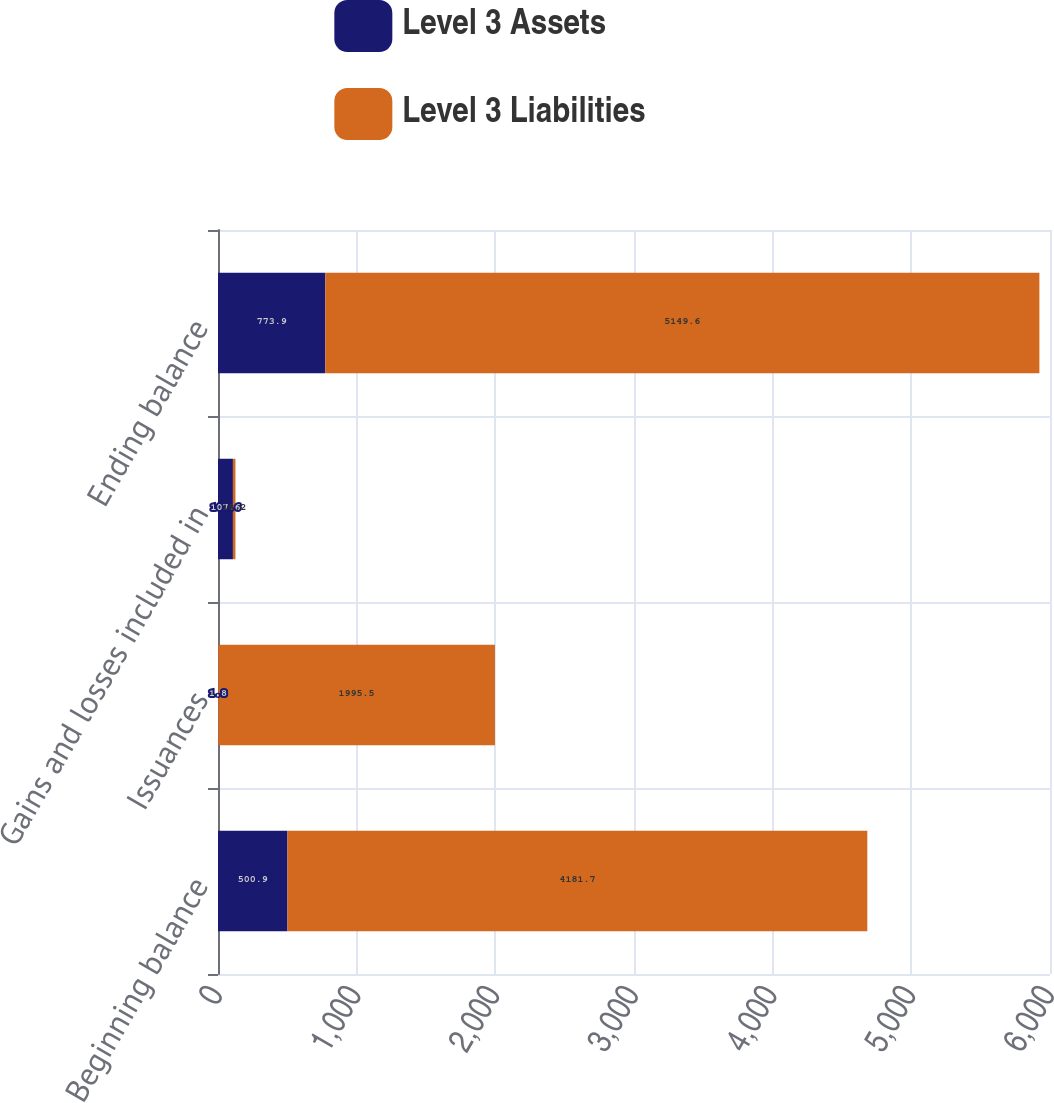Convert chart. <chart><loc_0><loc_0><loc_500><loc_500><stacked_bar_chart><ecel><fcel>Beginning balance<fcel>Issuances<fcel>Gains and losses included in<fcel>Ending balance<nl><fcel>Level 3 Assets<fcel>500.9<fcel>1.8<fcel>107.6<fcel>773.9<nl><fcel>Level 3 Liabilities<fcel>4181.7<fcel>1995.5<fcel>18.2<fcel>5149.6<nl></chart> 